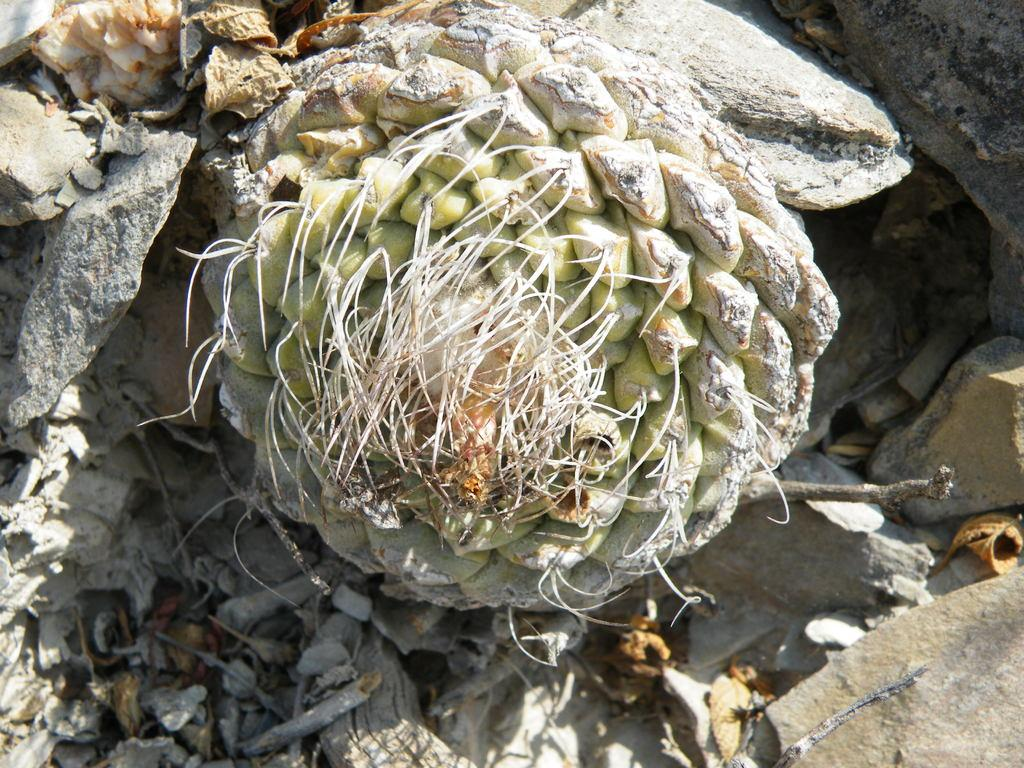What is the main subject in the middle of the image? There is a plant in the middle of the image. What can be seen on either side of the plant? There are stones on either side of the image. What type of punishment is being administered to the plant in the image? There is no punishment being administered to the plant in the image; it is simply a plant surrounded by stones. 